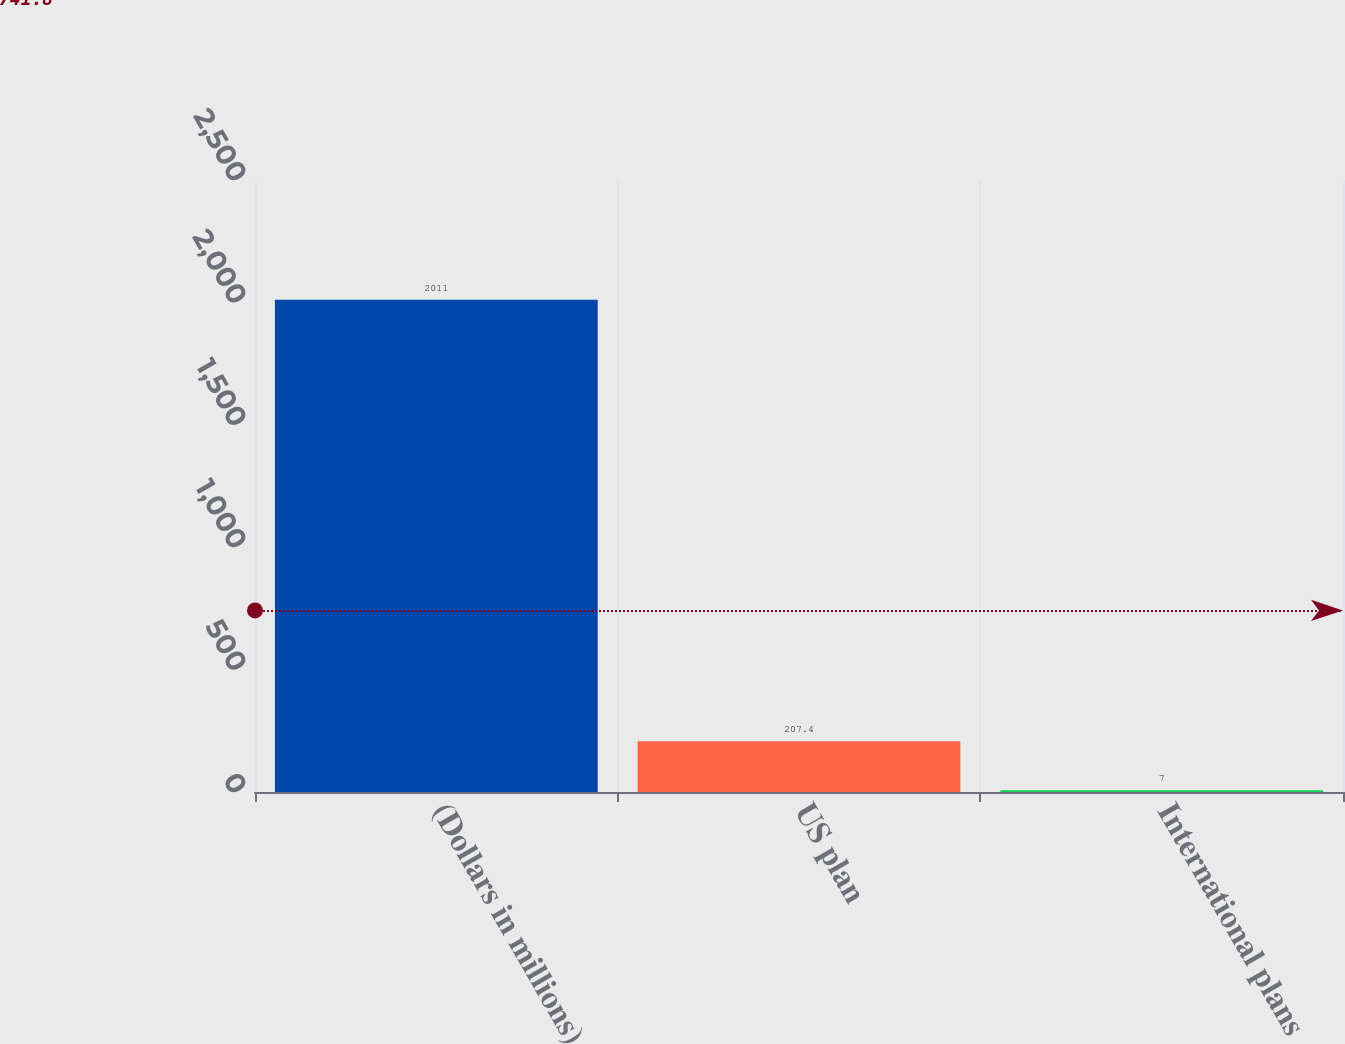Convert chart to OTSL. <chart><loc_0><loc_0><loc_500><loc_500><bar_chart><fcel>(Dollars in millions)<fcel>US plan<fcel>International plans<nl><fcel>2011<fcel>207.4<fcel>7<nl></chart> 